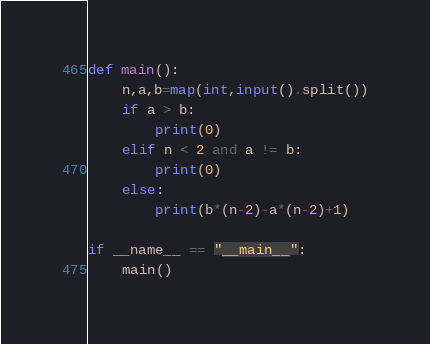<code> <loc_0><loc_0><loc_500><loc_500><_Python_>def main():
    n,a,b=map(int,input().split())
    if a > b:
        print(0)
    elif n < 2 and a != b:
        print(0)
    else:
        print(b*(n-2)-a*(n-2)+1)

if __name__ == "__main__":
    main()</code> 